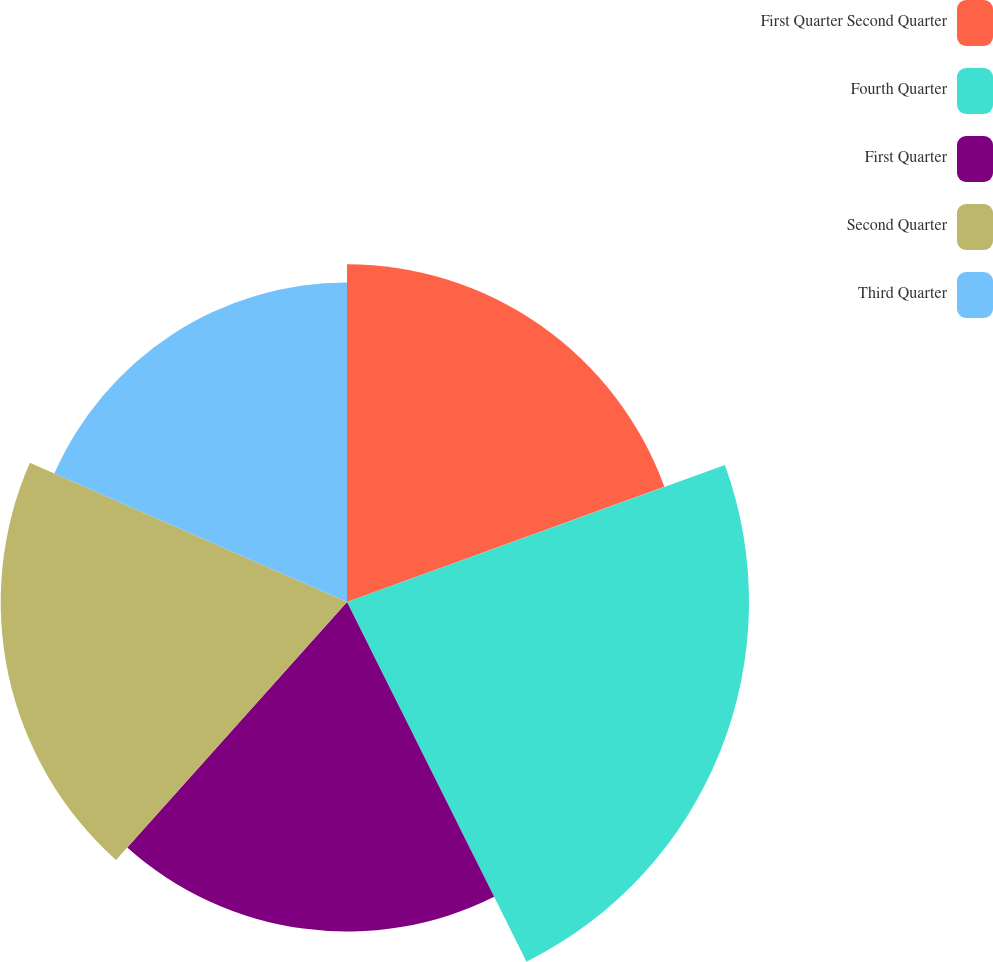<chart> <loc_0><loc_0><loc_500><loc_500><pie_chart><fcel>First Quarter Second Quarter<fcel>Fourth Quarter<fcel>First Quarter<fcel>Second Quarter<fcel>Third Quarter<nl><fcel>19.46%<fcel>23.17%<fcel>18.99%<fcel>19.96%<fcel>18.42%<nl></chart> 